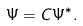<formula> <loc_0><loc_0><loc_500><loc_500>\Psi = C \Psi ^ { \ast } .</formula> 